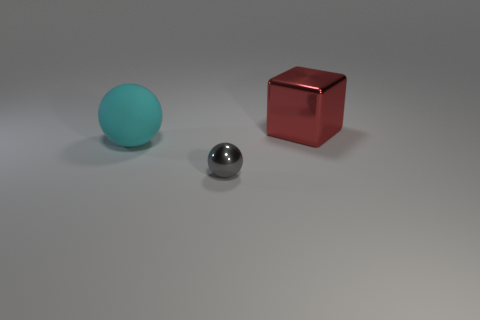Add 2 big purple rubber balls. How many objects exist? 5 Subtract 1 cubes. How many cubes are left? 0 Add 3 big purple matte balls. How many big purple matte balls exist? 3 Subtract all gray balls. How many balls are left? 1 Subtract 0 yellow cylinders. How many objects are left? 3 Subtract all spheres. How many objects are left? 1 Subtract all red spheres. Subtract all blue cylinders. How many spheres are left? 2 Subtract all yellow cylinders. How many cyan cubes are left? 0 Subtract all red blocks. Subtract all big rubber things. How many objects are left? 1 Add 3 gray metallic spheres. How many gray metallic spheres are left? 4 